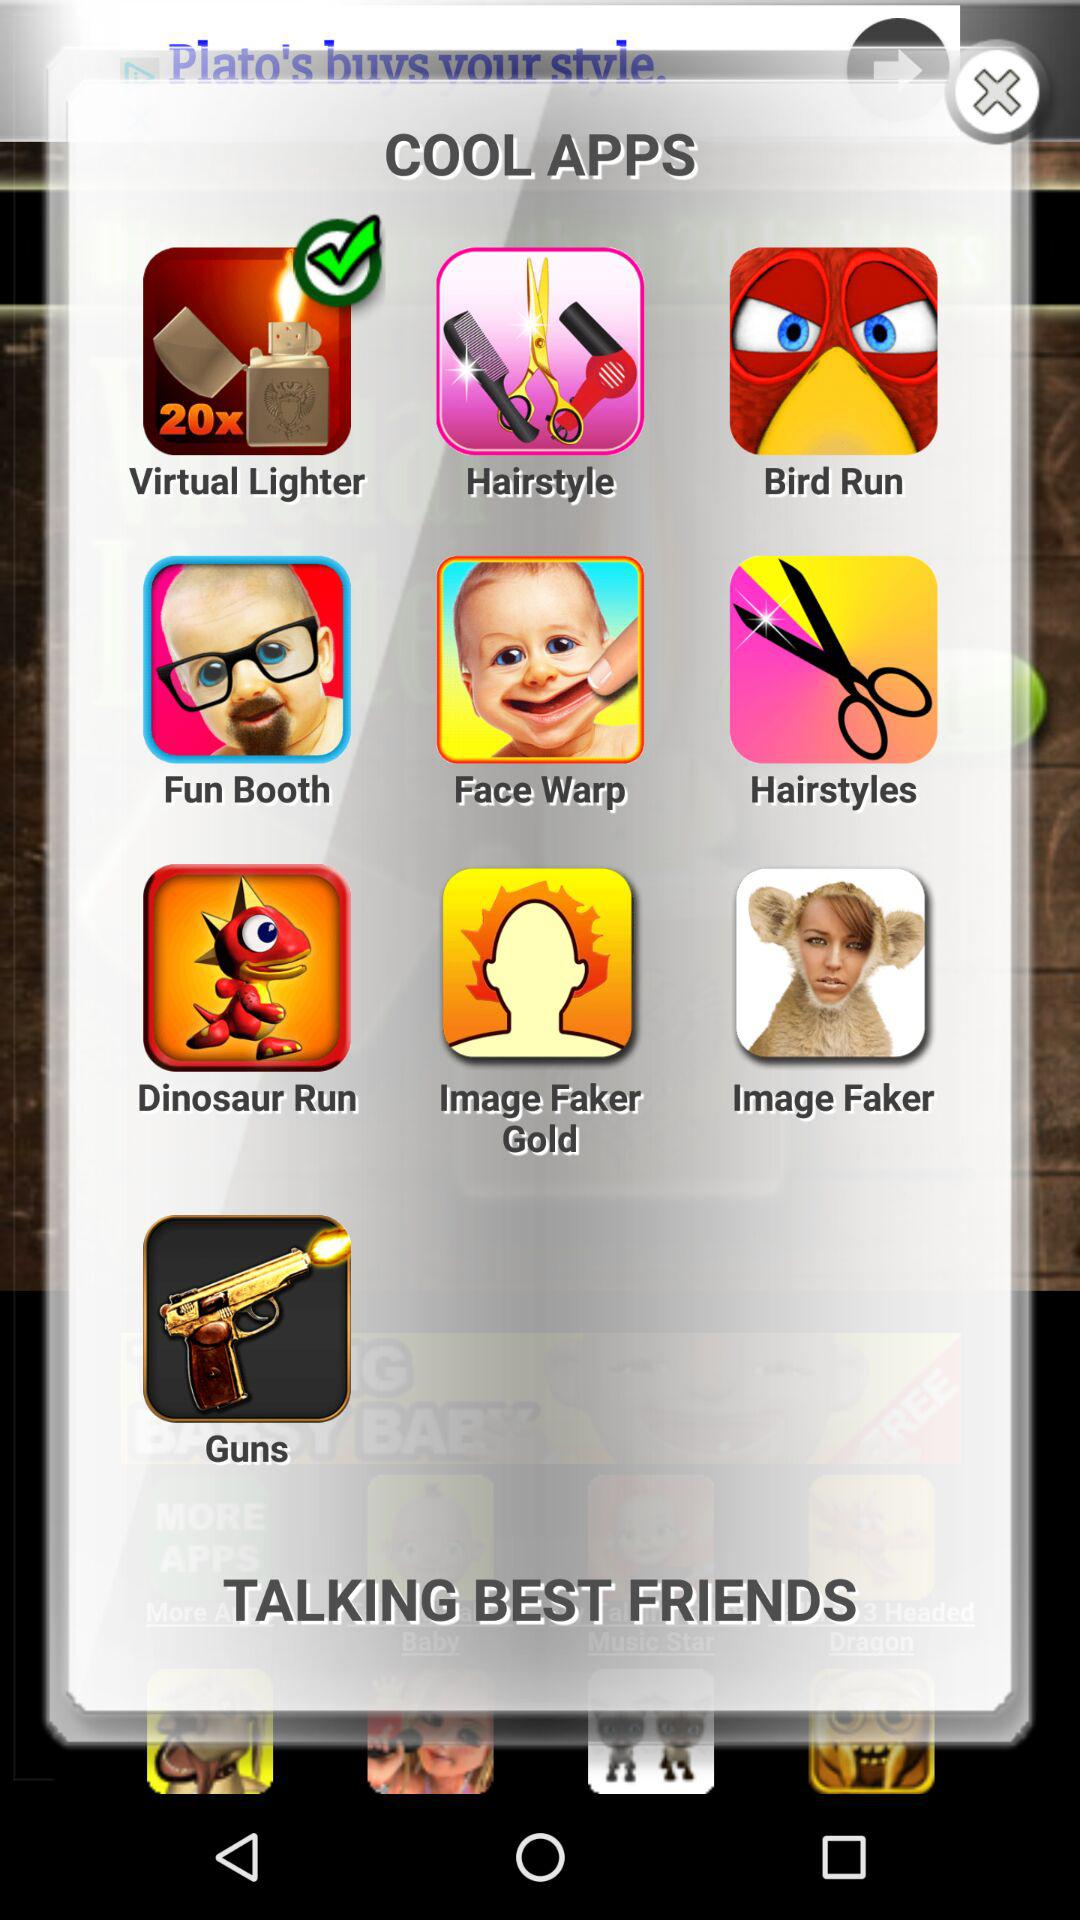Which option is selected? The selected option is "Virtual Lighter". 